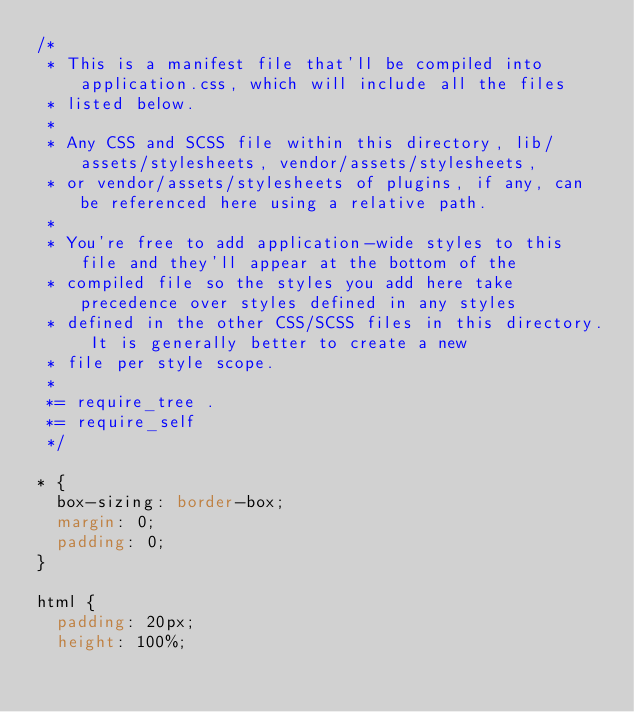Convert code to text. <code><loc_0><loc_0><loc_500><loc_500><_CSS_>/*
 * This is a manifest file that'll be compiled into application.css, which will include all the files
 * listed below.
 *
 * Any CSS and SCSS file within this directory, lib/assets/stylesheets, vendor/assets/stylesheets,
 * or vendor/assets/stylesheets of plugins, if any, can be referenced here using a relative path.
 *
 * You're free to add application-wide styles to this file and they'll appear at the bottom of the
 * compiled file so the styles you add here take precedence over styles defined in any styles
 * defined in the other CSS/SCSS files in this directory. It is generally better to create a new
 * file per style scope.
 *
 *= require_tree .
 *= require_self
 */

* {
  box-sizing: border-box;
  margin: 0;
  padding: 0;
}

html {
  padding: 20px;
  height: 100%;</code> 